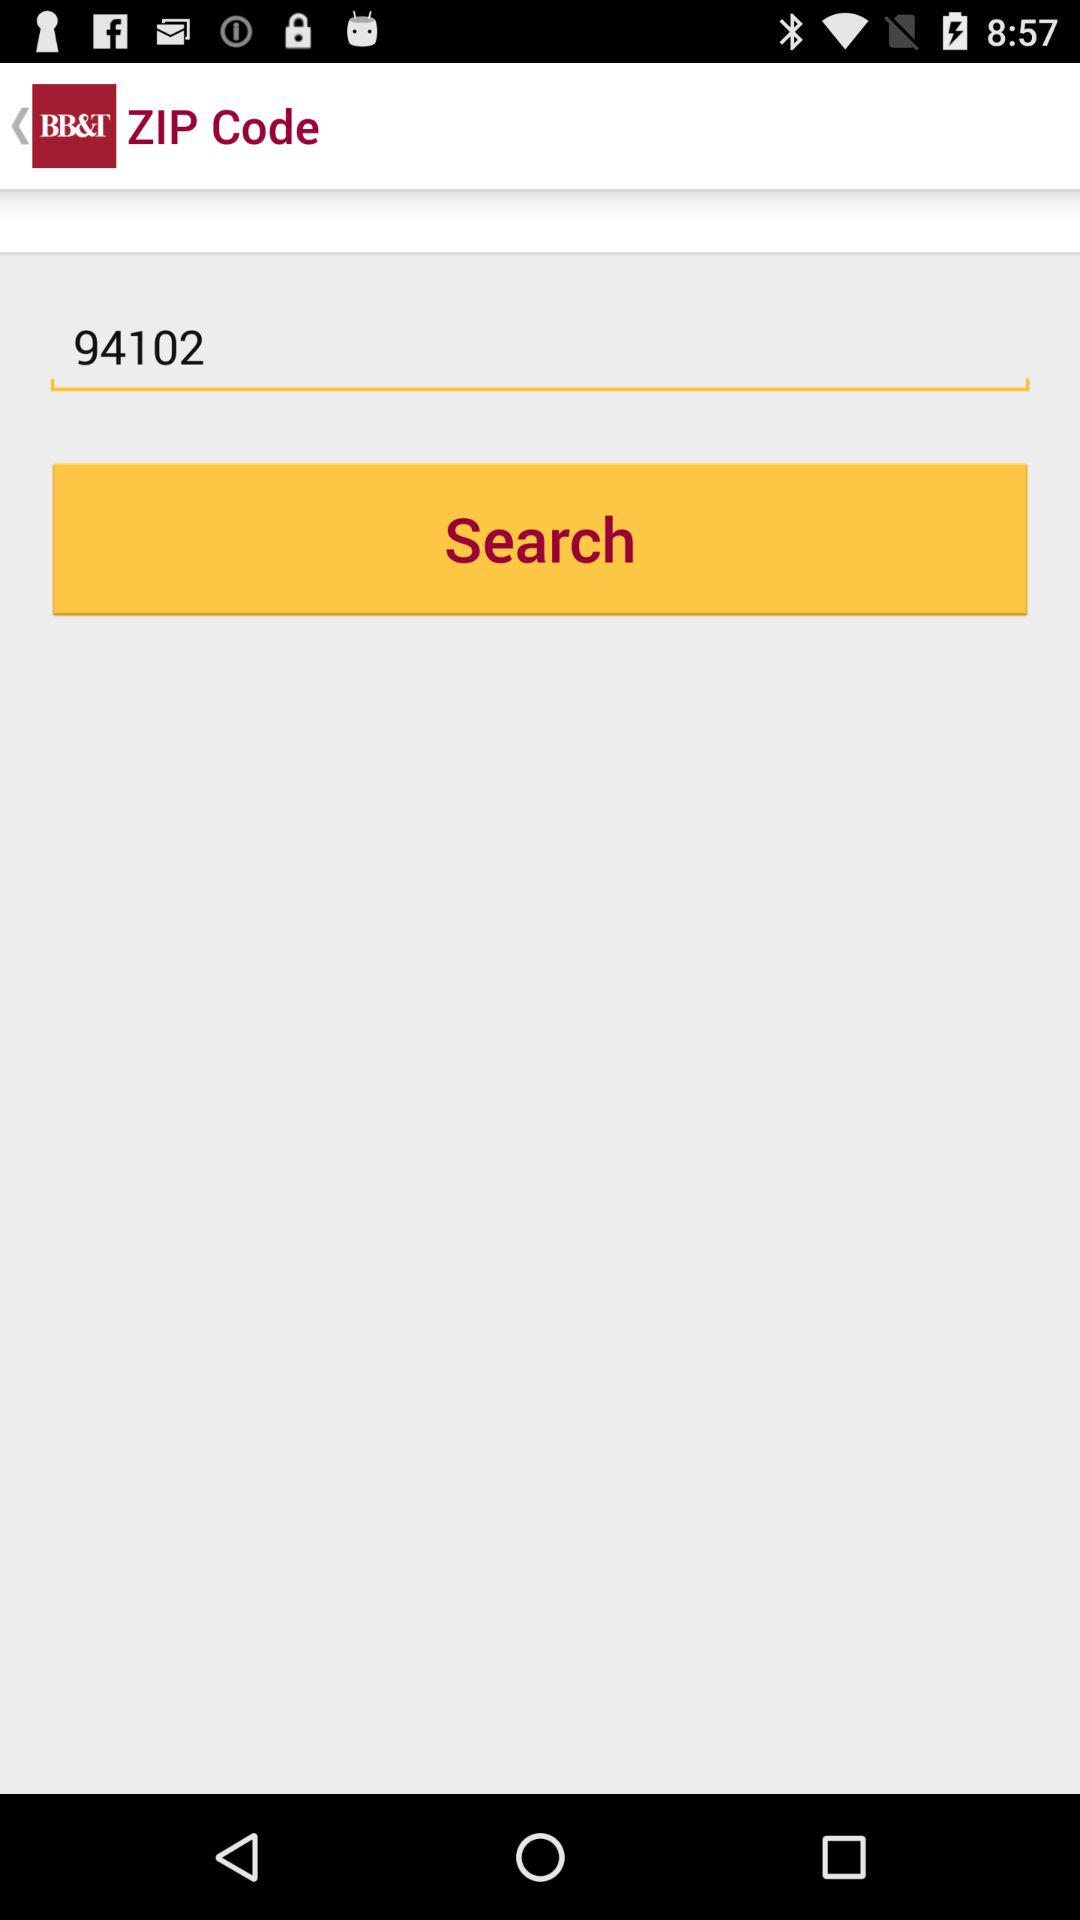What is the input entered in the search bar? The entered input is 94102. 